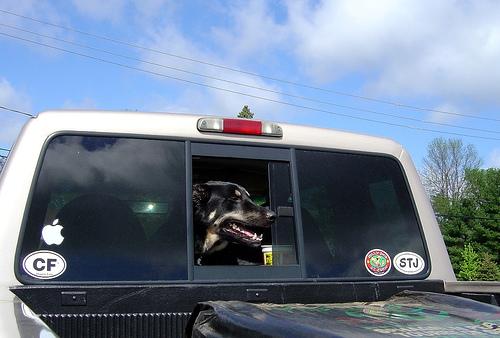Is the dog trying to jump out of the car?
Be succinct. No. What company logo is on the top left of the truck window?
Write a very short answer. Apple. Is there any pine trees?
Short answer required. Yes. How is dog driving when he is dog?
Quick response, please. He's not. 